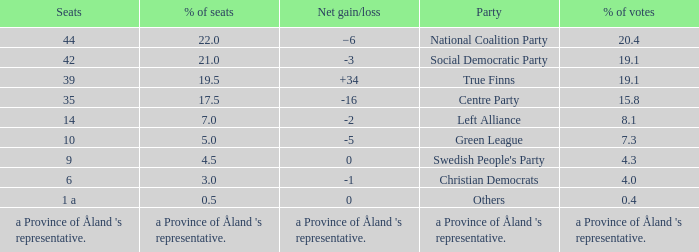Regarding the seats that casted 8.1% of the vote how many seats were held? 14.0. 